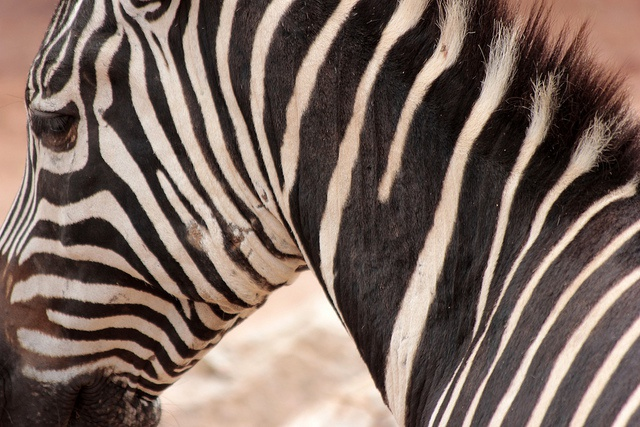Describe the objects in this image and their specific colors. I can see a zebra in black, gray, tan, and lightgray tones in this image. 